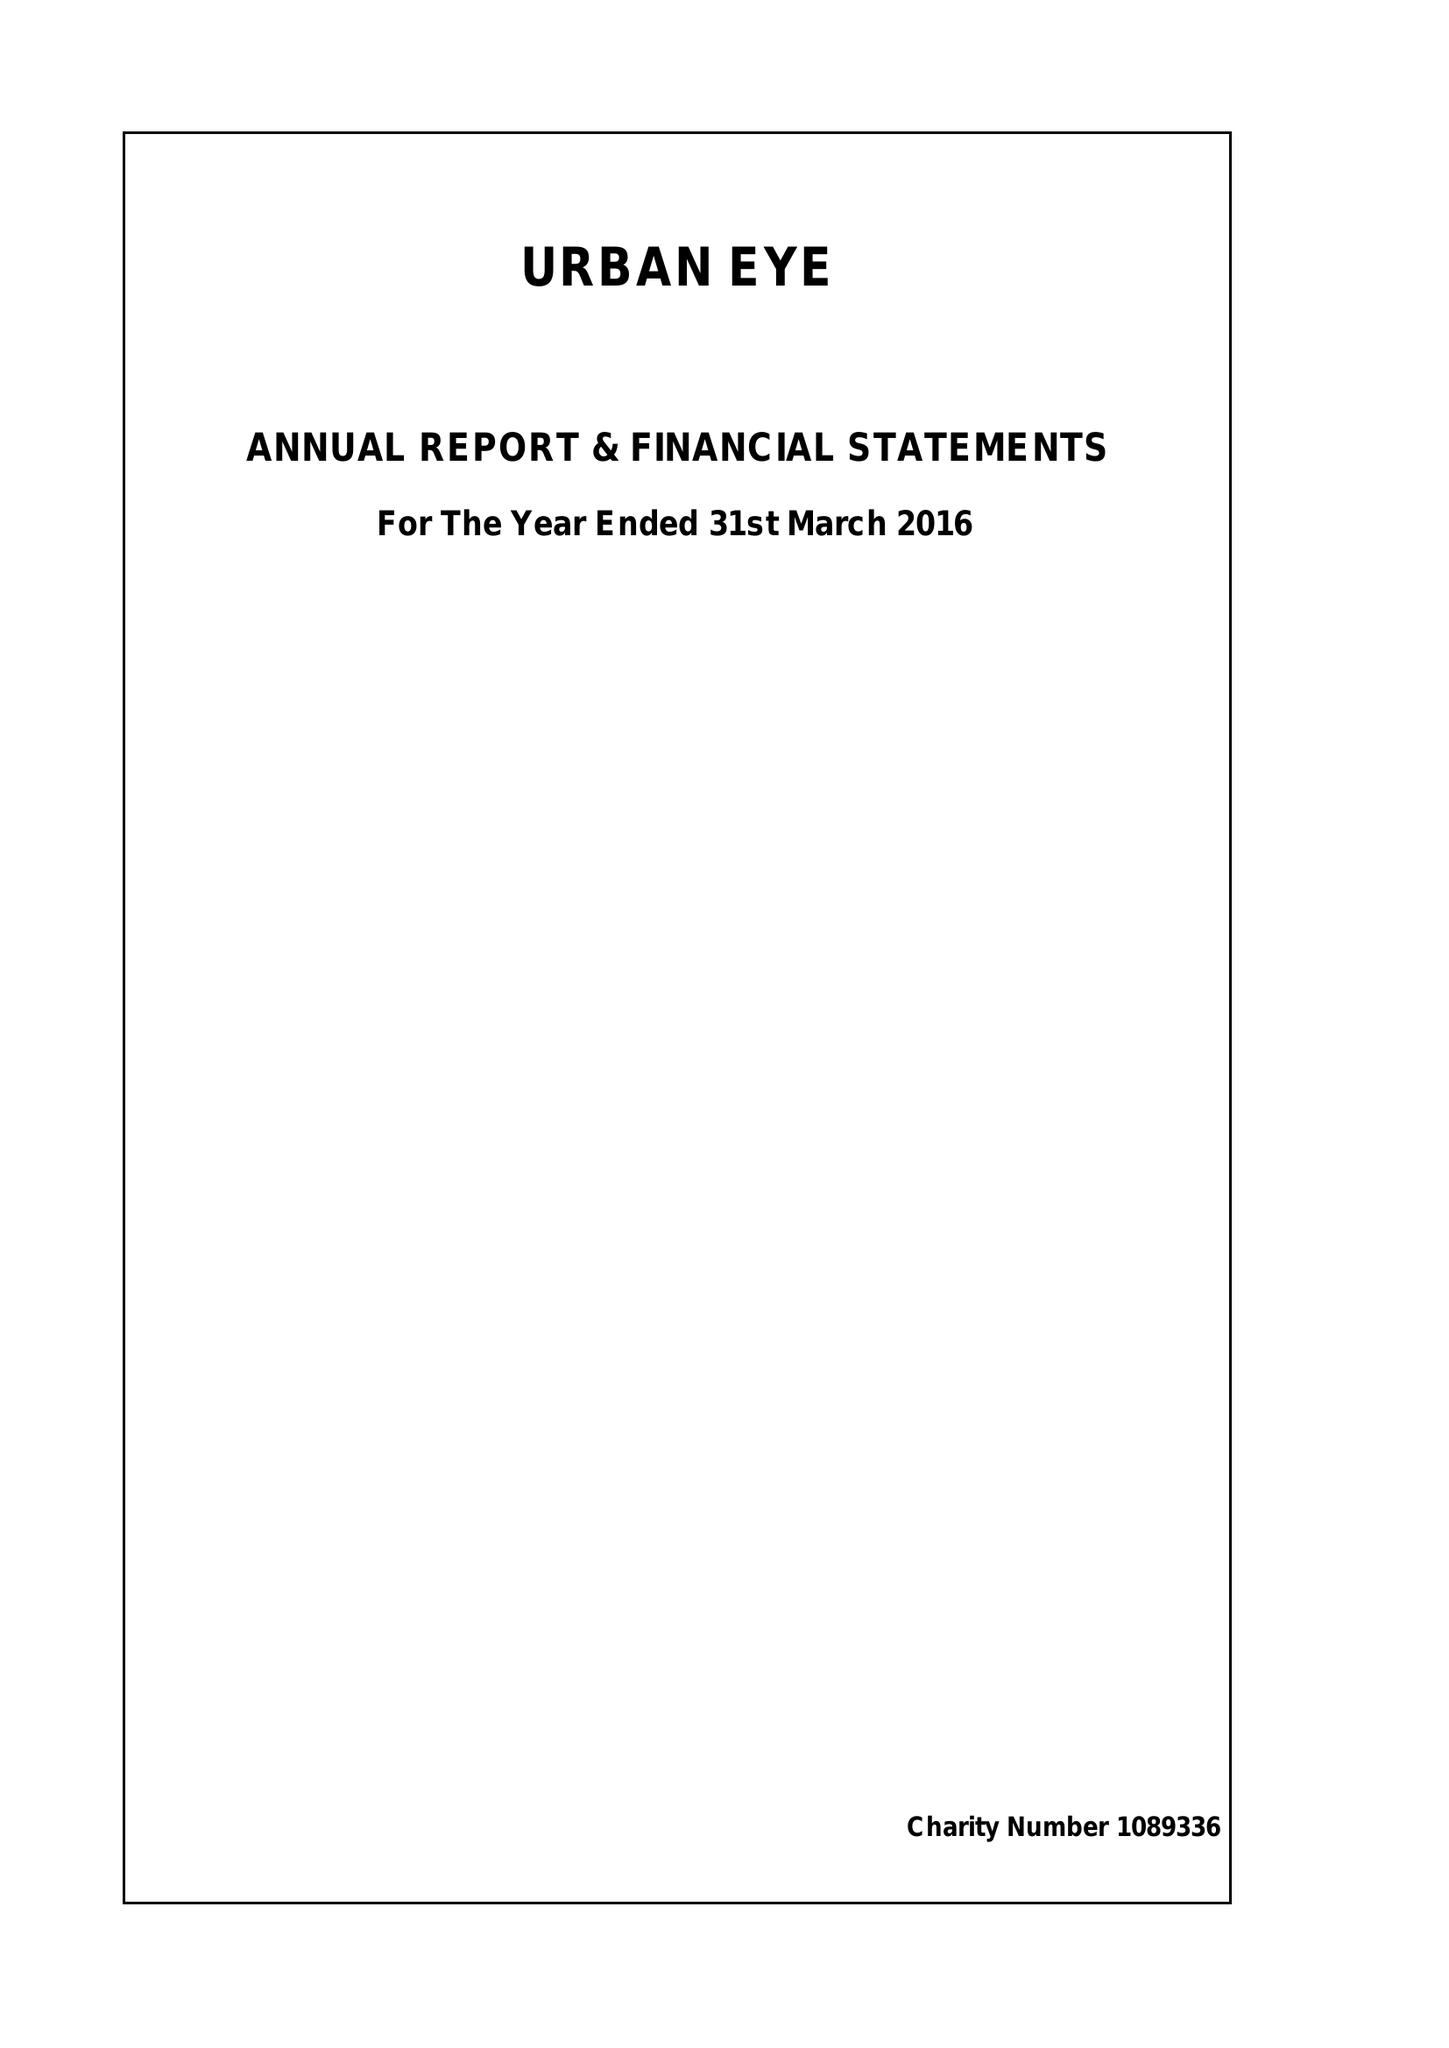What is the value for the charity_number?
Answer the question using a single word or phrase. 1089336 